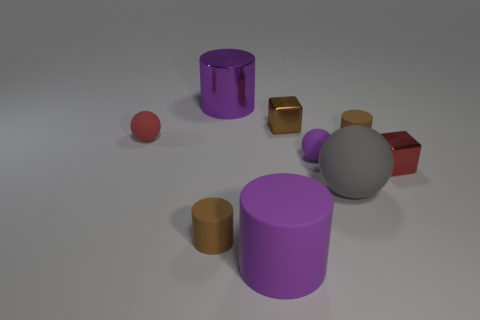Subtract all big purple rubber cylinders. How many cylinders are left? 3 Add 1 green metallic cylinders. How many objects exist? 10 Subtract all purple cylinders. How many cylinders are left? 2 Subtract all spheres. How many objects are left? 6 Subtract all gray spheres. How many brown cylinders are left? 2 Subtract 0 yellow cubes. How many objects are left? 9 Subtract 1 cubes. How many cubes are left? 1 Subtract all yellow spheres. Subtract all green blocks. How many spheres are left? 3 Subtract all tiny red spheres. Subtract all small red cubes. How many objects are left? 7 Add 7 small brown cylinders. How many small brown cylinders are left? 9 